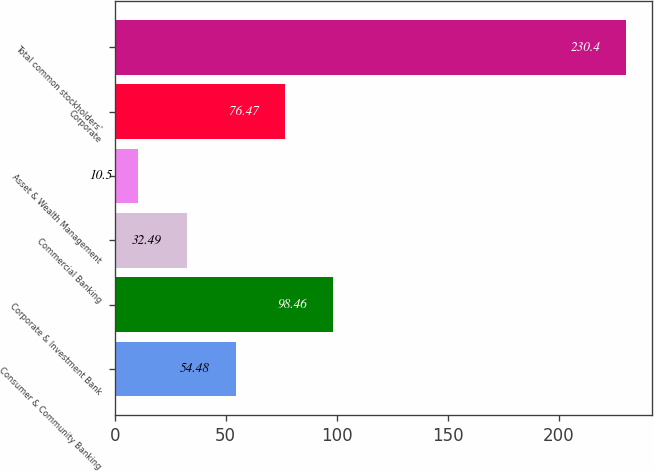Convert chart. <chart><loc_0><loc_0><loc_500><loc_500><bar_chart><fcel>Consumer & Community Banking<fcel>Corporate & Investment Bank<fcel>Commercial Banking<fcel>Asset & Wealth Management<fcel>Corporate<fcel>Total common stockholders'<nl><fcel>54.48<fcel>98.46<fcel>32.49<fcel>10.5<fcel>76.47<fcel>230.4<nl></chart> 